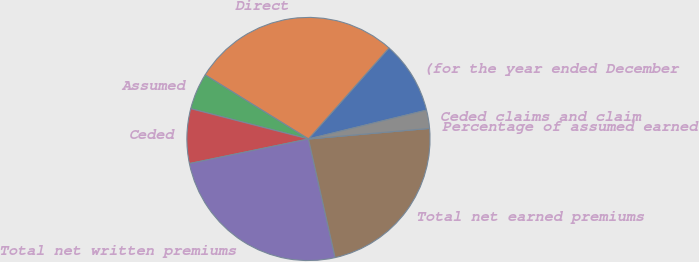<chart> <loc_0><loc_0><loc_500><loc_500><pie_chart><fcel>(for the year ended December<fcel>Direct<fcel>Assumed<fcel>Ceded<fcel>Total net written premiums<fcel>Total net earned premiums<fcel>Percentage of assumed earned<fcel>Ceded claims and claim<nl><fcel>9.66%<fcel>27.69%<fcel>4.83%<fcel>7.25%<fcel>25.28%<fcel>22.87%<fcel>0.0%<fcel>2.42%<nl></chart> 